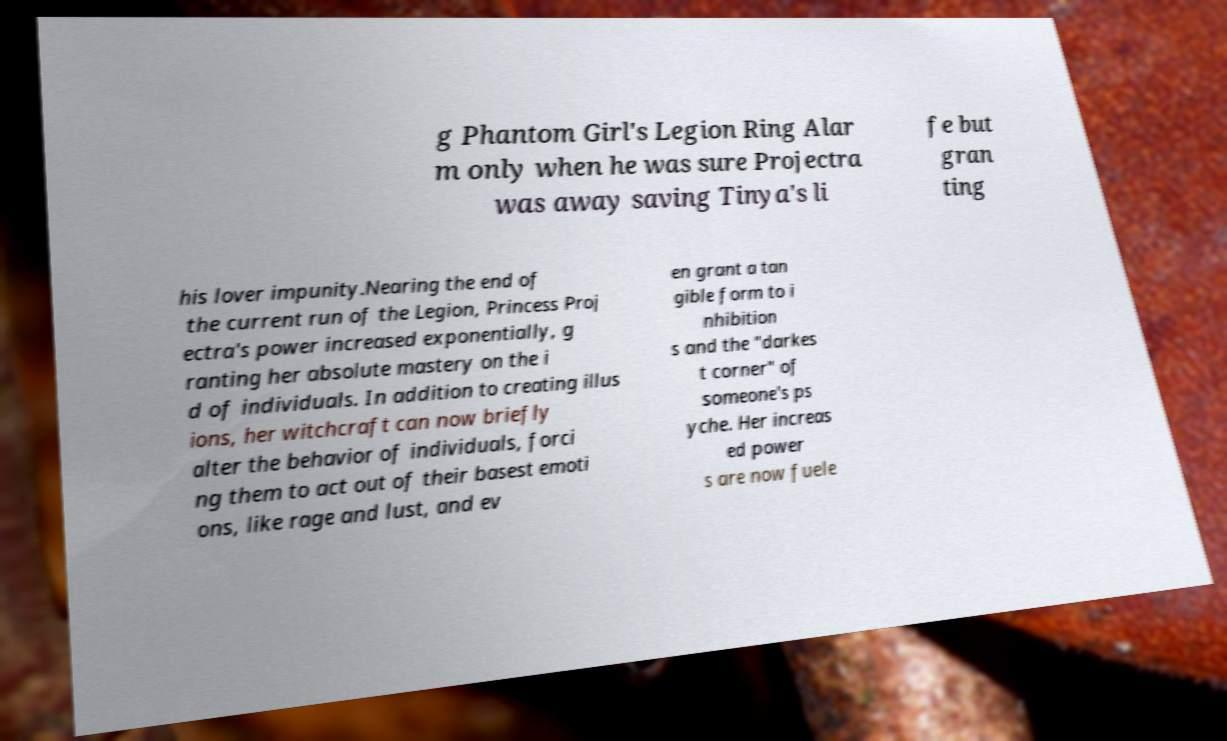There's text embedded in this image that I need extracted. Can you transcribe it verbatim? g Phantom Girl's Legion Ring Alar m only when he was sure Projectra was away saving Tinya's li fe but gran ting his lover impunity.Nearing the end of the current run of the Legion, Princess Proj ectra's power increased exponentially, g ranting her absolute mastery on the i d of individuals. In addition to creating illus ions, her witchcraft can now briefly alter the behavior of individuals, forci ng them to act out of their basest emoti ons, like rage and lust, and ev en grant a tan gible form to i nhibition s and the "darkes t corner" of someone's ps yche. Her increas ed power s are now fuele 